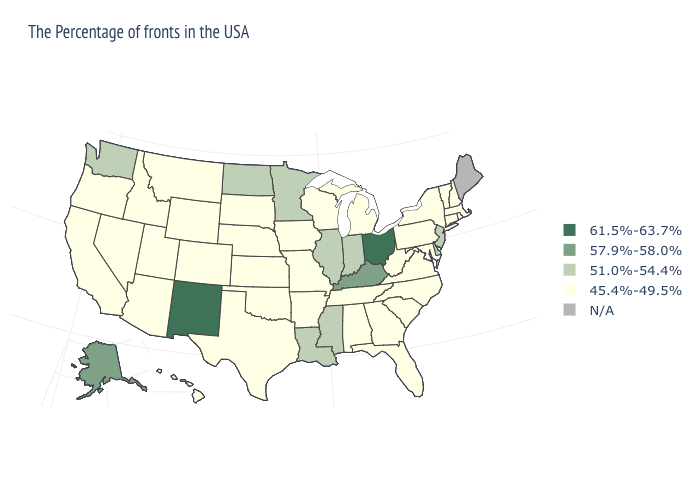What is the value of Maine?
Quick response, please. N/A. How many symbols are there in the legend?
Quick response, please. 5. Name the states that have a value in the range 57.9%-58.0%?
Quick response, please. Kentucky, Alaska. What is the highest value in the USA?
Be succinct. 61.5%-63.7%. Name the states that have a value in the range 61.5%-63.7%?
Short answer required. Ohio, New Mexico. Name the states that have a value in the range 45.4%-49.5%?
Quick response, please. Massachusetts, Rhode Island, New Hampshire, Vermont, Connecticut, New York, Maryland, Pennsylvania, Virginia, North Carolina, South Carolina, West Virginia, Florida, Georgia, Michigan, Alabama, Tennessee, Wisconsin, Missouri, Arkansas, Iowa, Kansas, Nebraska, Oklahoma, Texas, South Dakota, Wyoming, Colorado, Utah, Montana, Arizona, Idaho, Nevada, California, Oregon, Hawaii. What is the highest value in the Northeast ?
Answer briefly. 51.0%-54.4%. What is the lowest value in the West?
Quick response, please. 45.4%-49.5%. Which states have the lowest value in the USA?
Short answer required. Massachusetts, Rhode Island, New Hampshire, Vermont, Connecticut, New York, Maryland, Pennsylvania, Virginia, North Carolina, South Carolina, West Virginia, Florida, Georgia, Michigan, Alabama, Tennessee, Wisconsin, Missouri, Arkansas, Iowa, Kansas, Nebraska, Oklahoma, Texas, South Dakota, Wyoming, Colorado, Utah, Montana, Arizona, Idaho, Nevada, California, Oregon, Hawaii. What is the lowest value in the USA?
Keep it brief. 45.4%-49.5%. Does New Mexico have the highest value in the USA?
Be succinct. Yes. What is the highest value in the USA?
Answer briefly. 61.5%-63.7%. What is the value of Texas?
Give a very brief answer. 45.4%-49.5%. Which states have the lowest value in the USA?
Keep it brief. Massachusetts, Rhode Island, New Hampshire, Vermont, Connecticut, New York, Maryland, Pennsylvania, Virginia, North Carolina, South Carolina, West Virginia, Florida, Georgia, Michigan, Alabama, Tennessee, Wisconsin, Missouri, Arkansas, Iowa, Kansas, Nebraska, Oklahoma, Texas, South Dakota, Wyoming, Colorado, Utah, Montana, Arizona, Idaho, Nevada, California, Oregon, Hawaii. What is the value of Maryland?
Quick response, please. 45.4%-49.5%. 